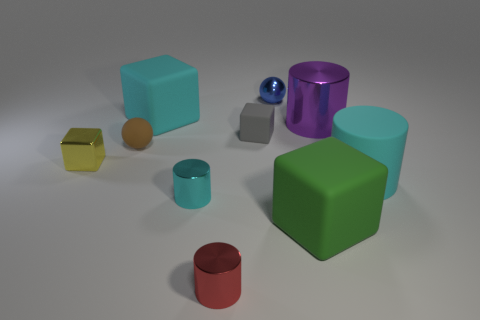Subtract all blocks. How many objects are left? 6 Subtract all small metallic blocks. Subtract all small brown matte spheres. How many objects are left? 8 Add 5 gray rubber blocks. How many gray rubber blocks are left? 6 Add 1 tiny gray rubber things. How many tiny gray rubber things exist? 2 Subtract 0 yellow balls. How many objects are left? 10 